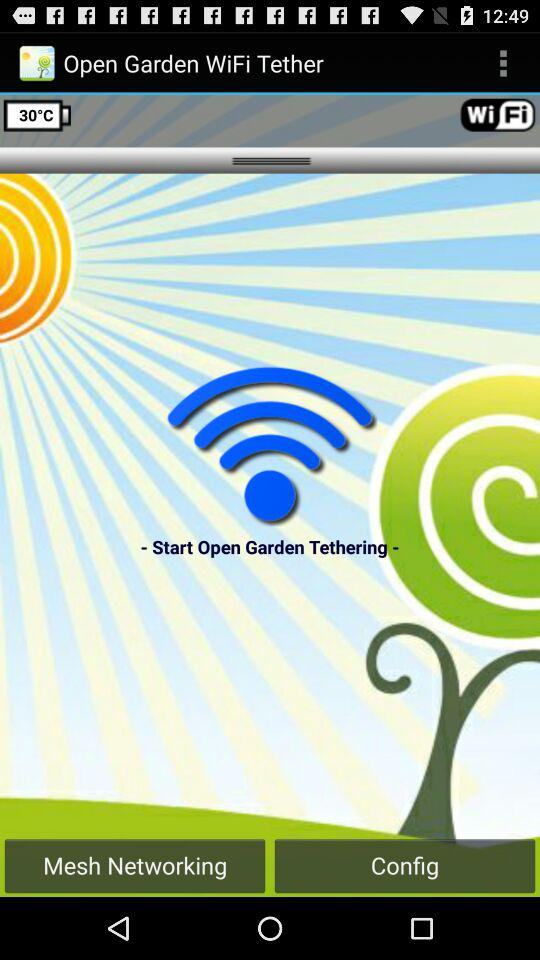What is the temperature in Fahrenheit?
When the provided information is insufficient, respond with <no answer>. <no answer> 